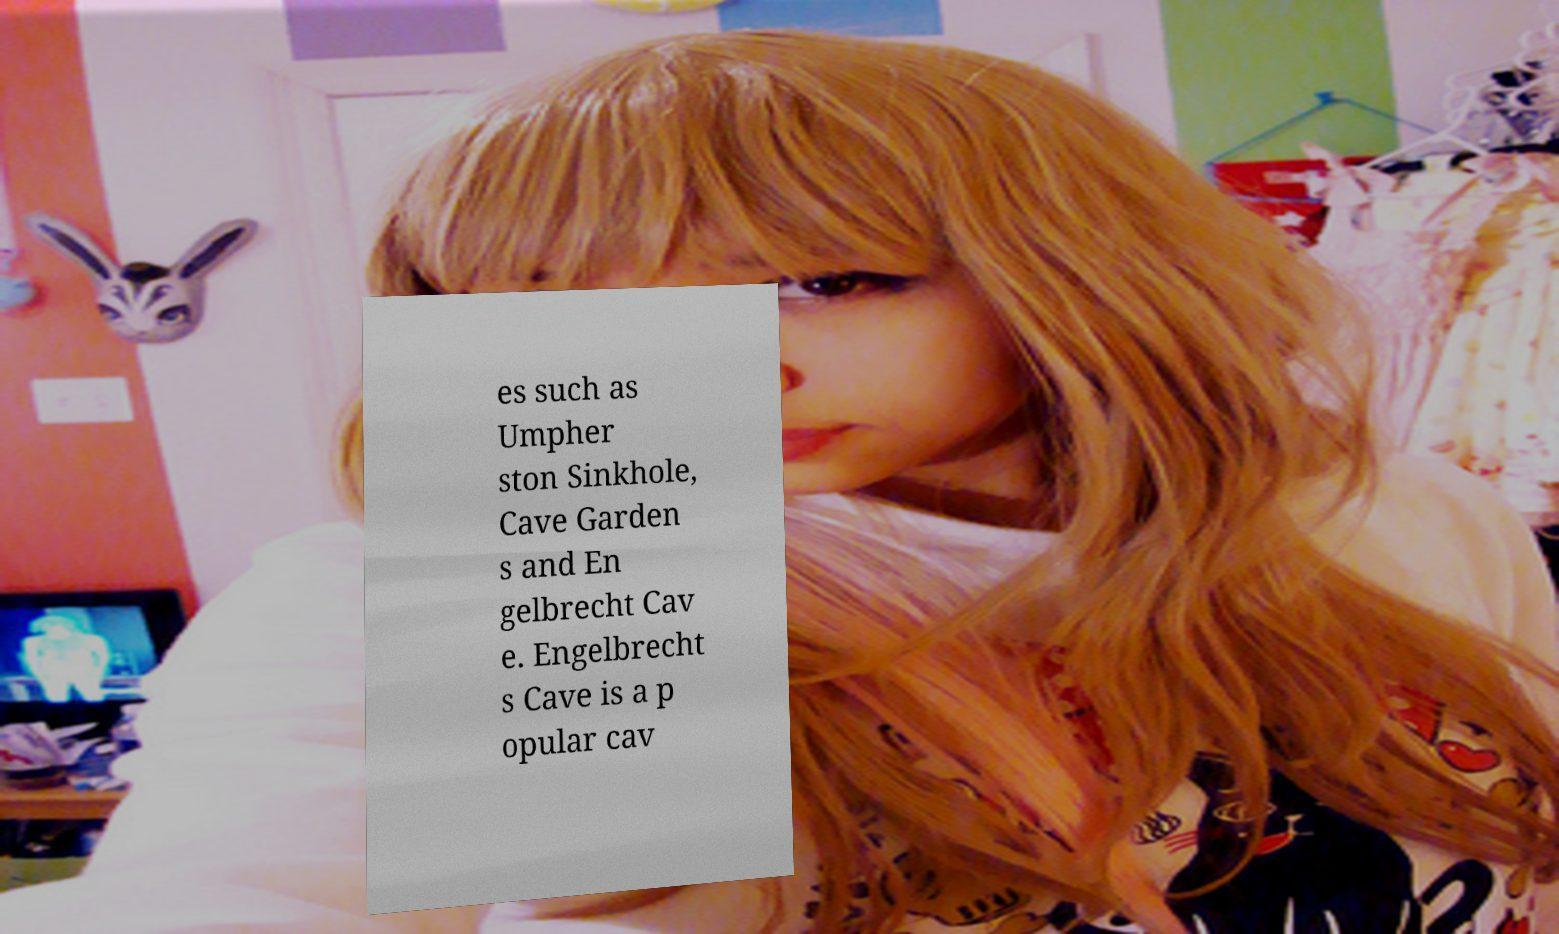What messages or text are displayed in this image? I need them in a readable, typed format. es such as Umpher ston Sinkhole, Cave Garden s and En gelbrecht Cav e. Engelbrecht s Cave is a p opular cav 